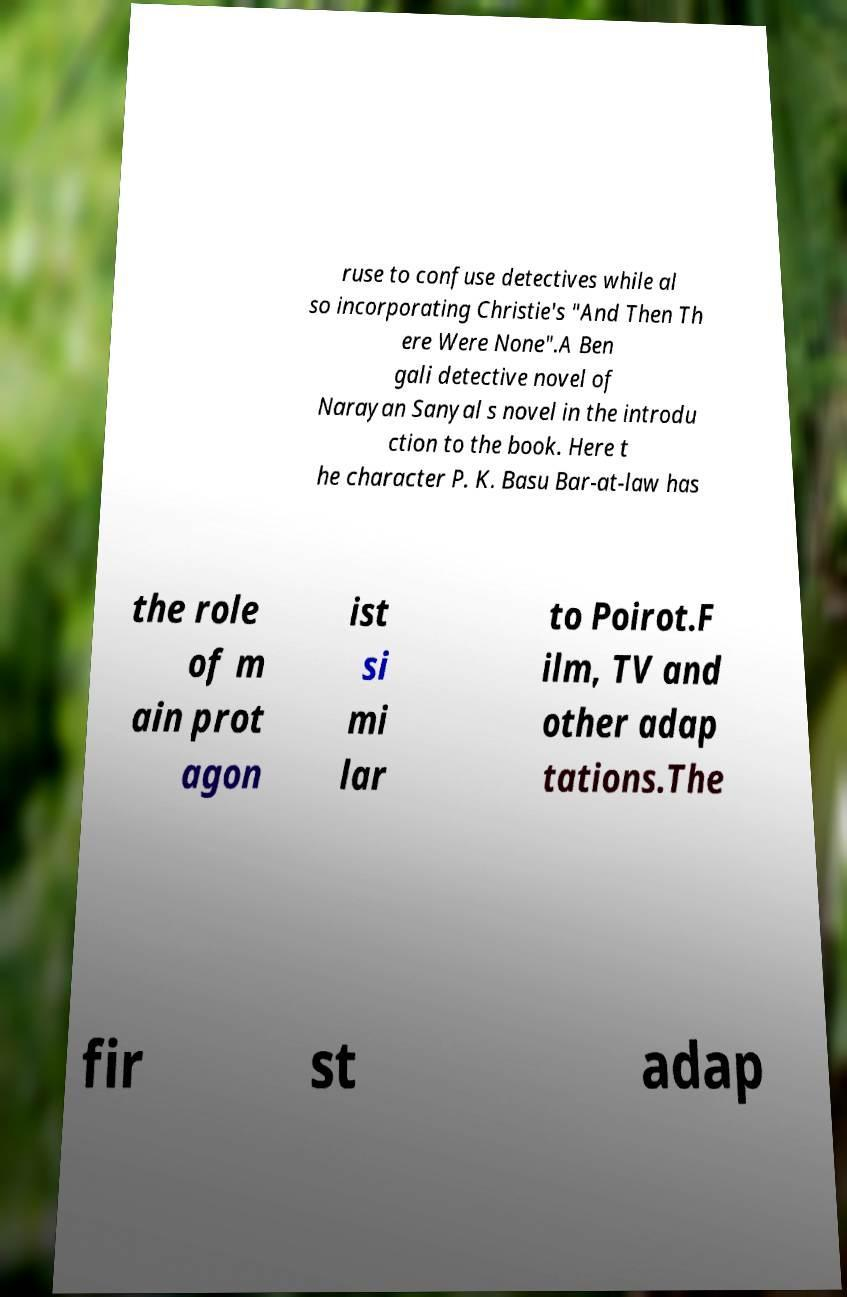Please read and relay the text visible in this image. What does it say? ruse to confuse detectives while al so incorporating Christie's "And Then Th ere Were None".A Ben gali detective novel of Narayan Sanyal s novel in the introdu ction to the book. Here t he character P. K. Basu Bar-at-law has the role of m ain prot agon ist si mi lar to Poirot.F ilm, TV and other adap tations.The fir st adap 